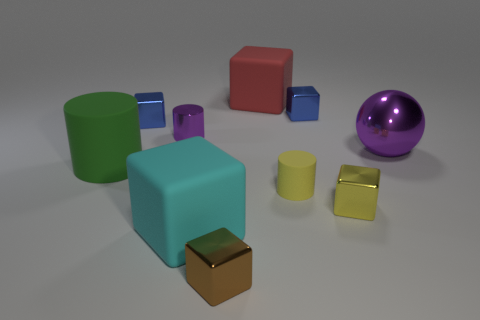Subtract all matte cubes. How many cubes are left? 4 Subtract all yellow blocks. How many blocks are left? 5 Subtract all brown blocks. Subtract all red cylinders. How many blocks are left? 5 Subtract all cylinders. How many objects are left? 7 Subtract 1 purple spheres. How many objects are left? 9 Subtract all green matte cylinders. Subtract all matte things. How many objects are left? 5 Add 7 shiny balls. How many shiny balls are left? 8 Add 10 large brown cubes. How many large brown cubes exist? 10 